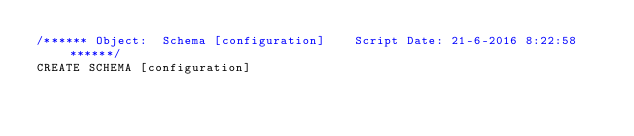<code> <loc_0><loc_0><loc_500><loc_500><_SQL_>/****** Object:  Schema [configuration]    Script Date: 21-6-2016 8:22:58 ******/
CREATE SCHEMA [configuration]</code> 